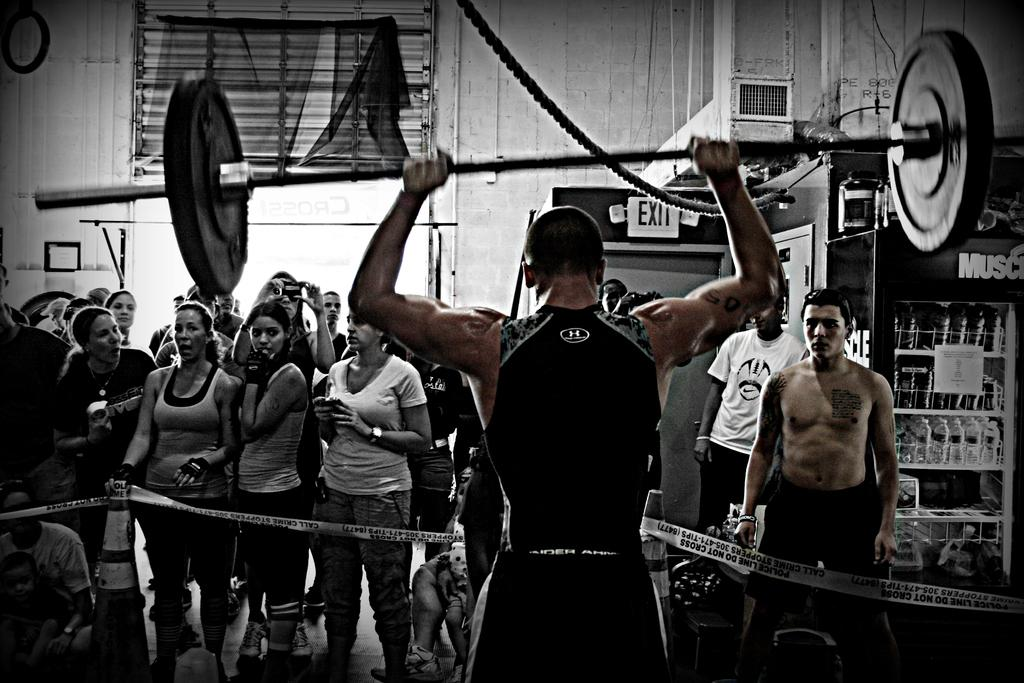What is the color of the wall in the image? The wall in the image is white. What can be seen on the wall in the image? There is a window on the wall in the image. What else is present in the image besides the wall and window? There are people in the image, including a man lifting a weight lifter. What type of badge is the weight lifter wearing in the image? There is no badge visible on the weight lifter in the image. In which direction is the man lifting the weight lifter facing? The direction the man is facing while lifting the weight lifter cannot be determined from the image. 